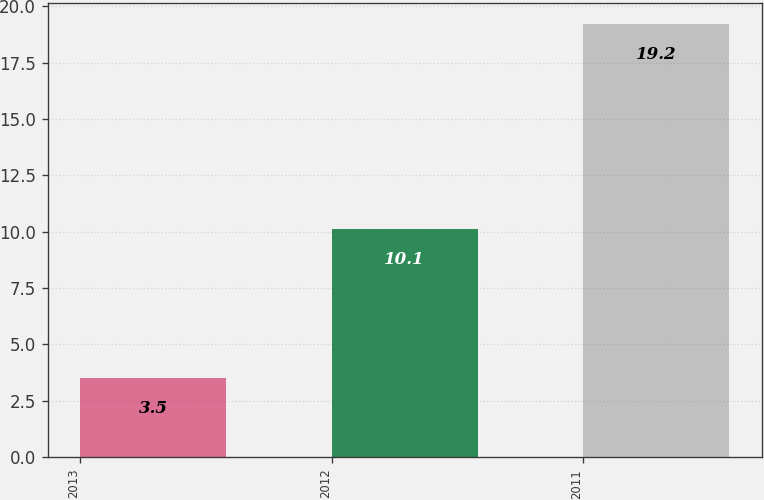<chart> <loc_0><loc_0><loc_500><loc_500><bar_chart><fcel>2013<fcel>2012<fcel>2011<nl><fcel>3.5<fcel>10.1<fcel>19.2<nl></chart> 